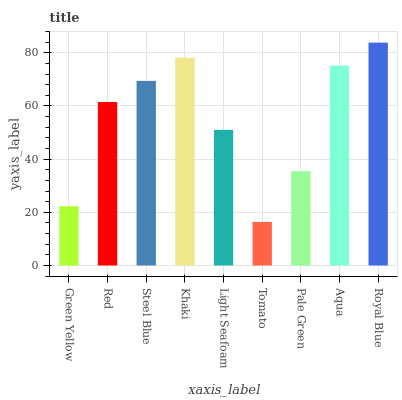Is Tomato the minimum?
Answer yes or no. Yes. Is Royal Blue the maximum?
Answer yes or no. Yes. Is Red the minimum?
Answer yes or no. No. Is Red the maximum?
Answer yes or no. No. Is Red greater than Green Yellow?
Answer yes or no. Yes. Is Green Yellow less than Red?
Answer yes or no. Yes. Is Green Yellow greater than Red?
Answer yes or no. No. Is Red less than Green Yellow?
Answer yes or no. No. Is Red the high median?
Answer yes or no. Yes. Is Red the low median?
Answer yes or no. Yes. Is Steel Blue the high median?
Answer yes or no. No. Is Khaki the low median?
Answer yes or no. No. 